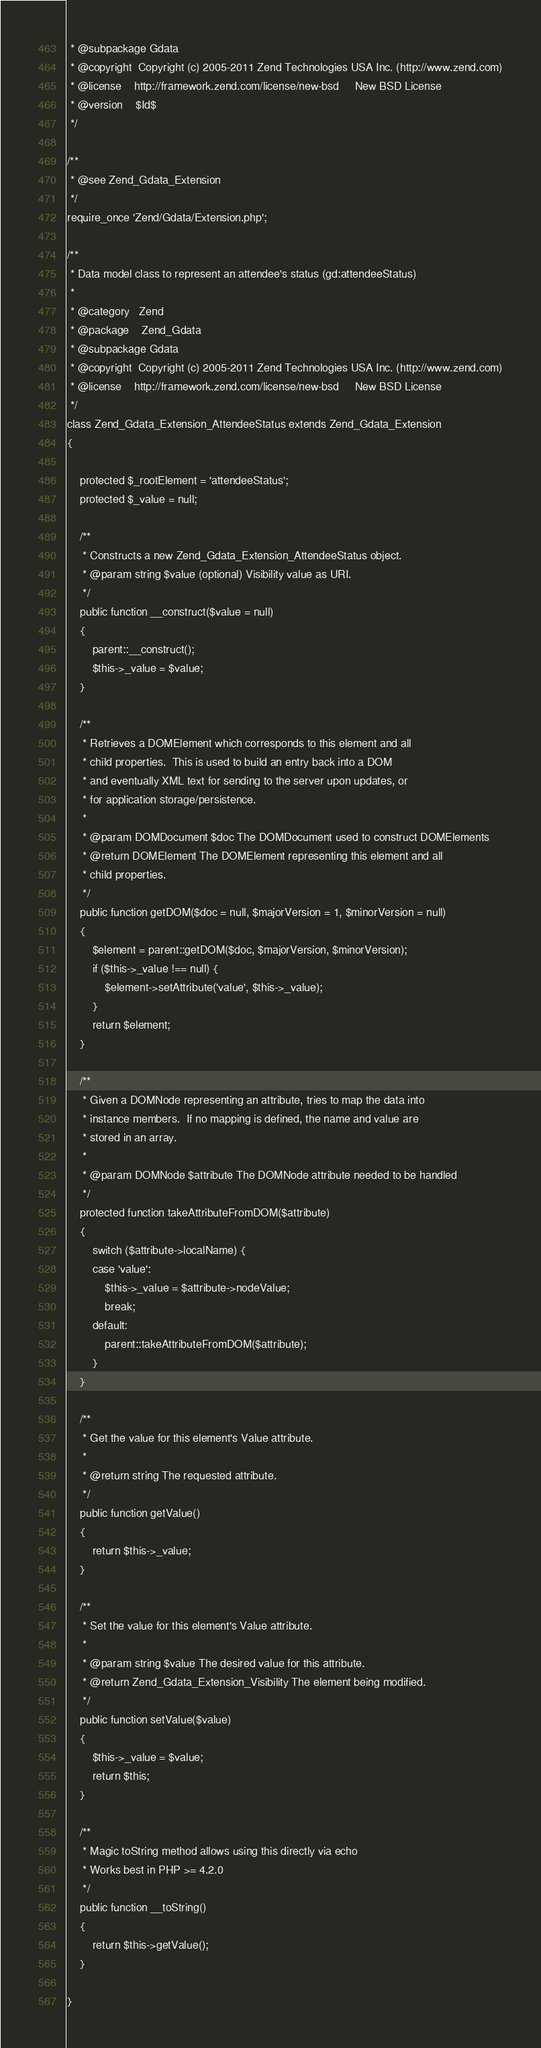Convert code to text. <code><loc_0><loc_0><loc_500><loc_500><_PHP_> * @subpackage Gdata
 * @copyright  Copyright (c) 2005-2011 Zend Technologies USA Inc. (http://www.zend.com)
 * @license    http://framework.zend.com/license/new-bsd     New BSD License
 * @version    $Id$
 */

/**
 * @see Zend_Gdata_Extension
 */
require_once 'Zend/Gdata/Extension.php';

/**
 * Data model class to represent an attendee's status (gd:attendeeStatus)
 *
 * @category   Zend
 * @package    Zend_Gdata
 * @subpackage Gdata
 * @copyright  Copyright (c) 2005-2011 Zend Technologies USA Inc. (http://www.zend.com)
 * @license    http://framework.zend.com/license/new-bsd     New BSD License
 */
class Zend_Gdata_Extension_AttendeeStatus extends Zend_Gdata_Extension
{

    protected $_rootElement = 'attendeeStatus';
    protected $_value = null;

    /**
     * Constructs a new Zend_Gdata_Extension_AttendeeStatus object.
     * @param string $value (optional) Visibility value as URI.
     */
    public function __construct($value = null)
    {
        parent::__construct();
        $this->_value = $value;
    }

    /**
     * Retrieves a DOMElement which corresponds to this element and all
     * child properties.  This is used to build an entry back into a DOM
     * and eventually XML text for sending to the server upon updates, or
     * for application storage/persistence.
     *
     * @param DOMDocument $doc The DOMDocument used to construct DOMElements
     * @return DOMElement The DOMElement representing this element and all
     * child properties.
     */
    public function getDOM($doc = null, $majorVersion = 1, $minorVersion = null)
    {
        $element = parent::getDOM($doc, $majorVersion, $minorVersion);
        if ($this->_value !== null) {
            $element->setAttribute('value', $this->_value);
        }
        return $element;
    }

    /**
     * Given a DOMNode representing an attribute, tries to map the data into
     * instance members.  If no mapping is defined, the name and value are
     * stored in an array.
     *
     * @param DOMNode $attribute The DOMNode attribute needed to be handled
     */
    protected function takeAttributeFromDOM($attribute)
    {
        switch ($attribute->localName) {
        case 'value':
            $this->_value = $attribute->nodeValue;
            break;
        default:
            parent::takeAttributeFromDOM($attribute);
        }
    }

    /**
     * Get the value for this element's Value attribute.
     *
     * @return string The requested attribute.
     */
    public function getValue()
    {
        return $this->_value;
    }

    /**
     * Set the value for this element's Value attribute.
     *
     * @param string $value The desired value for this attribute.
     * @return Zend_Gdata_Extension_Visibility The element being modified.
     */
    public function setValue($value)
    {
        $this->_value = $value;
        return $this;
    }

    /**
     * Magic toString method allows using this directly via echo
     * Works best in PHP >= 4.2.0
     */
    public function __toString()
    {
        return $this->getValue();
    }

}

</code> 